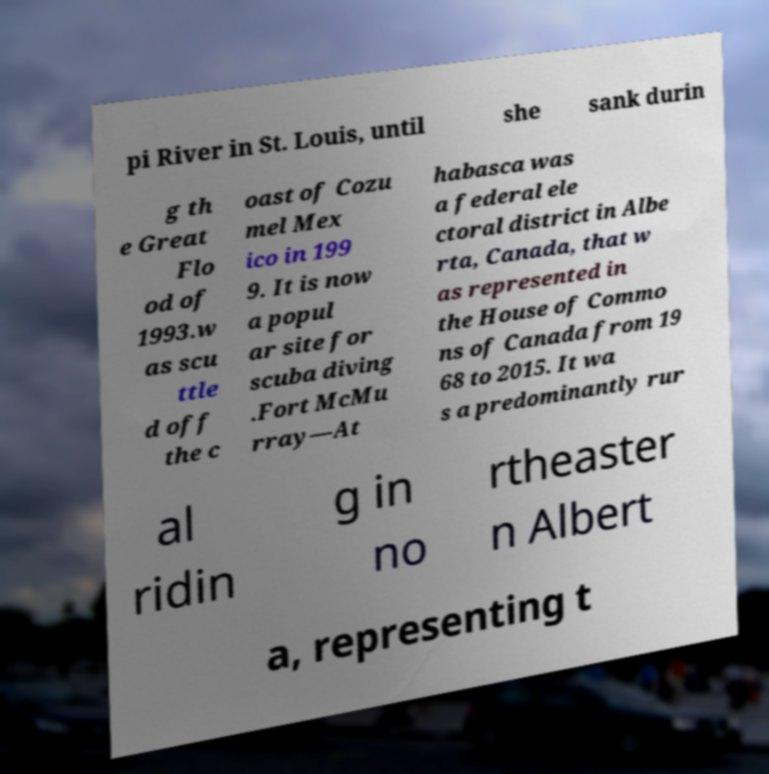Can you read and provide the text displayed in the image?This photo seems to have some interesting text. Can you extract and type it out for me? pi River in St. Louis, until she sank durin g th e Great Flo od of 1993.w as scu ttle d off the c oast of Cozu mel Mex ico in 199 9. It is now a popul ar site for scuba diving .Fort McMu rray—At habasca was a federal ele ctoral district in Albe rta, Canada, that w as represented in the House of Commo ns of Canada from 19 68 to 2015. It wa s a predominantly rur al ridin g in no rtheaster n Albert a, representing t 